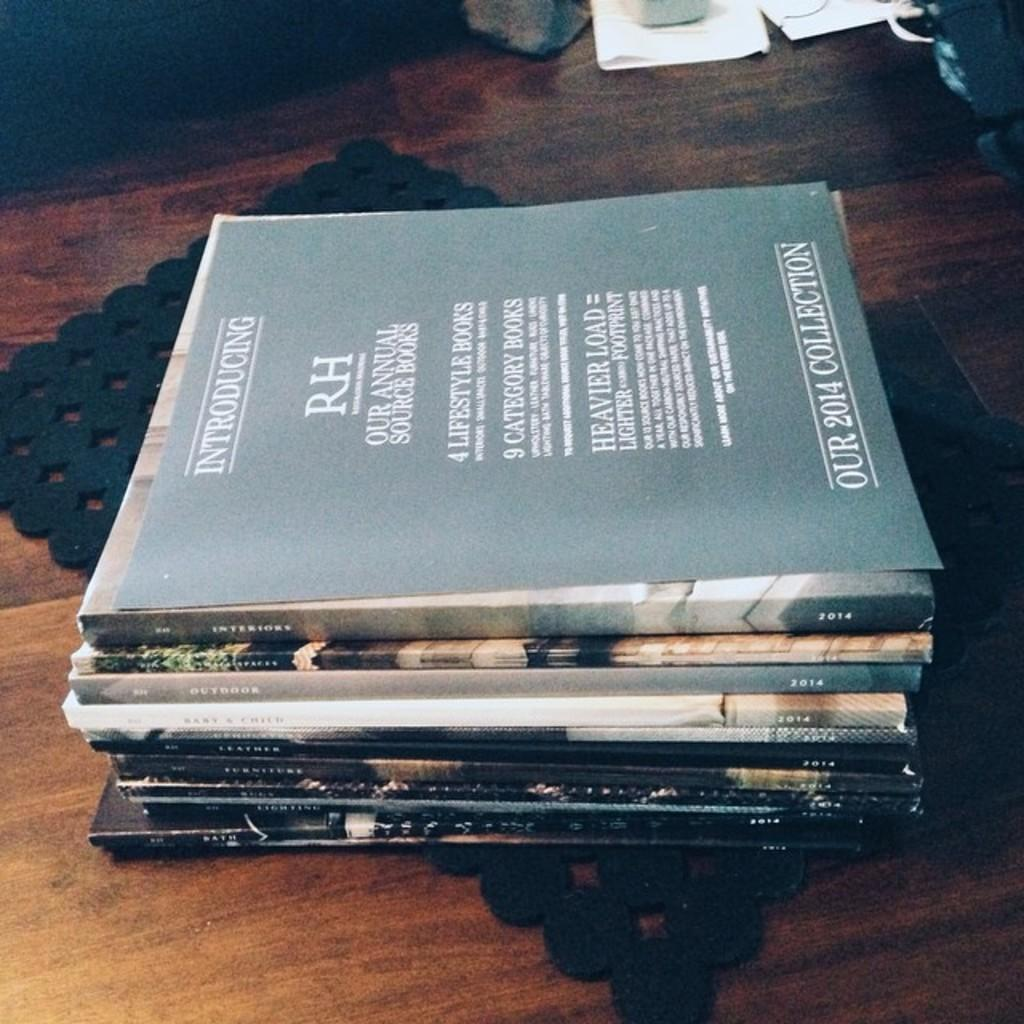Provide a one-sentence caption for the provided image. A collection of books that all appear to be from the year 2014. 